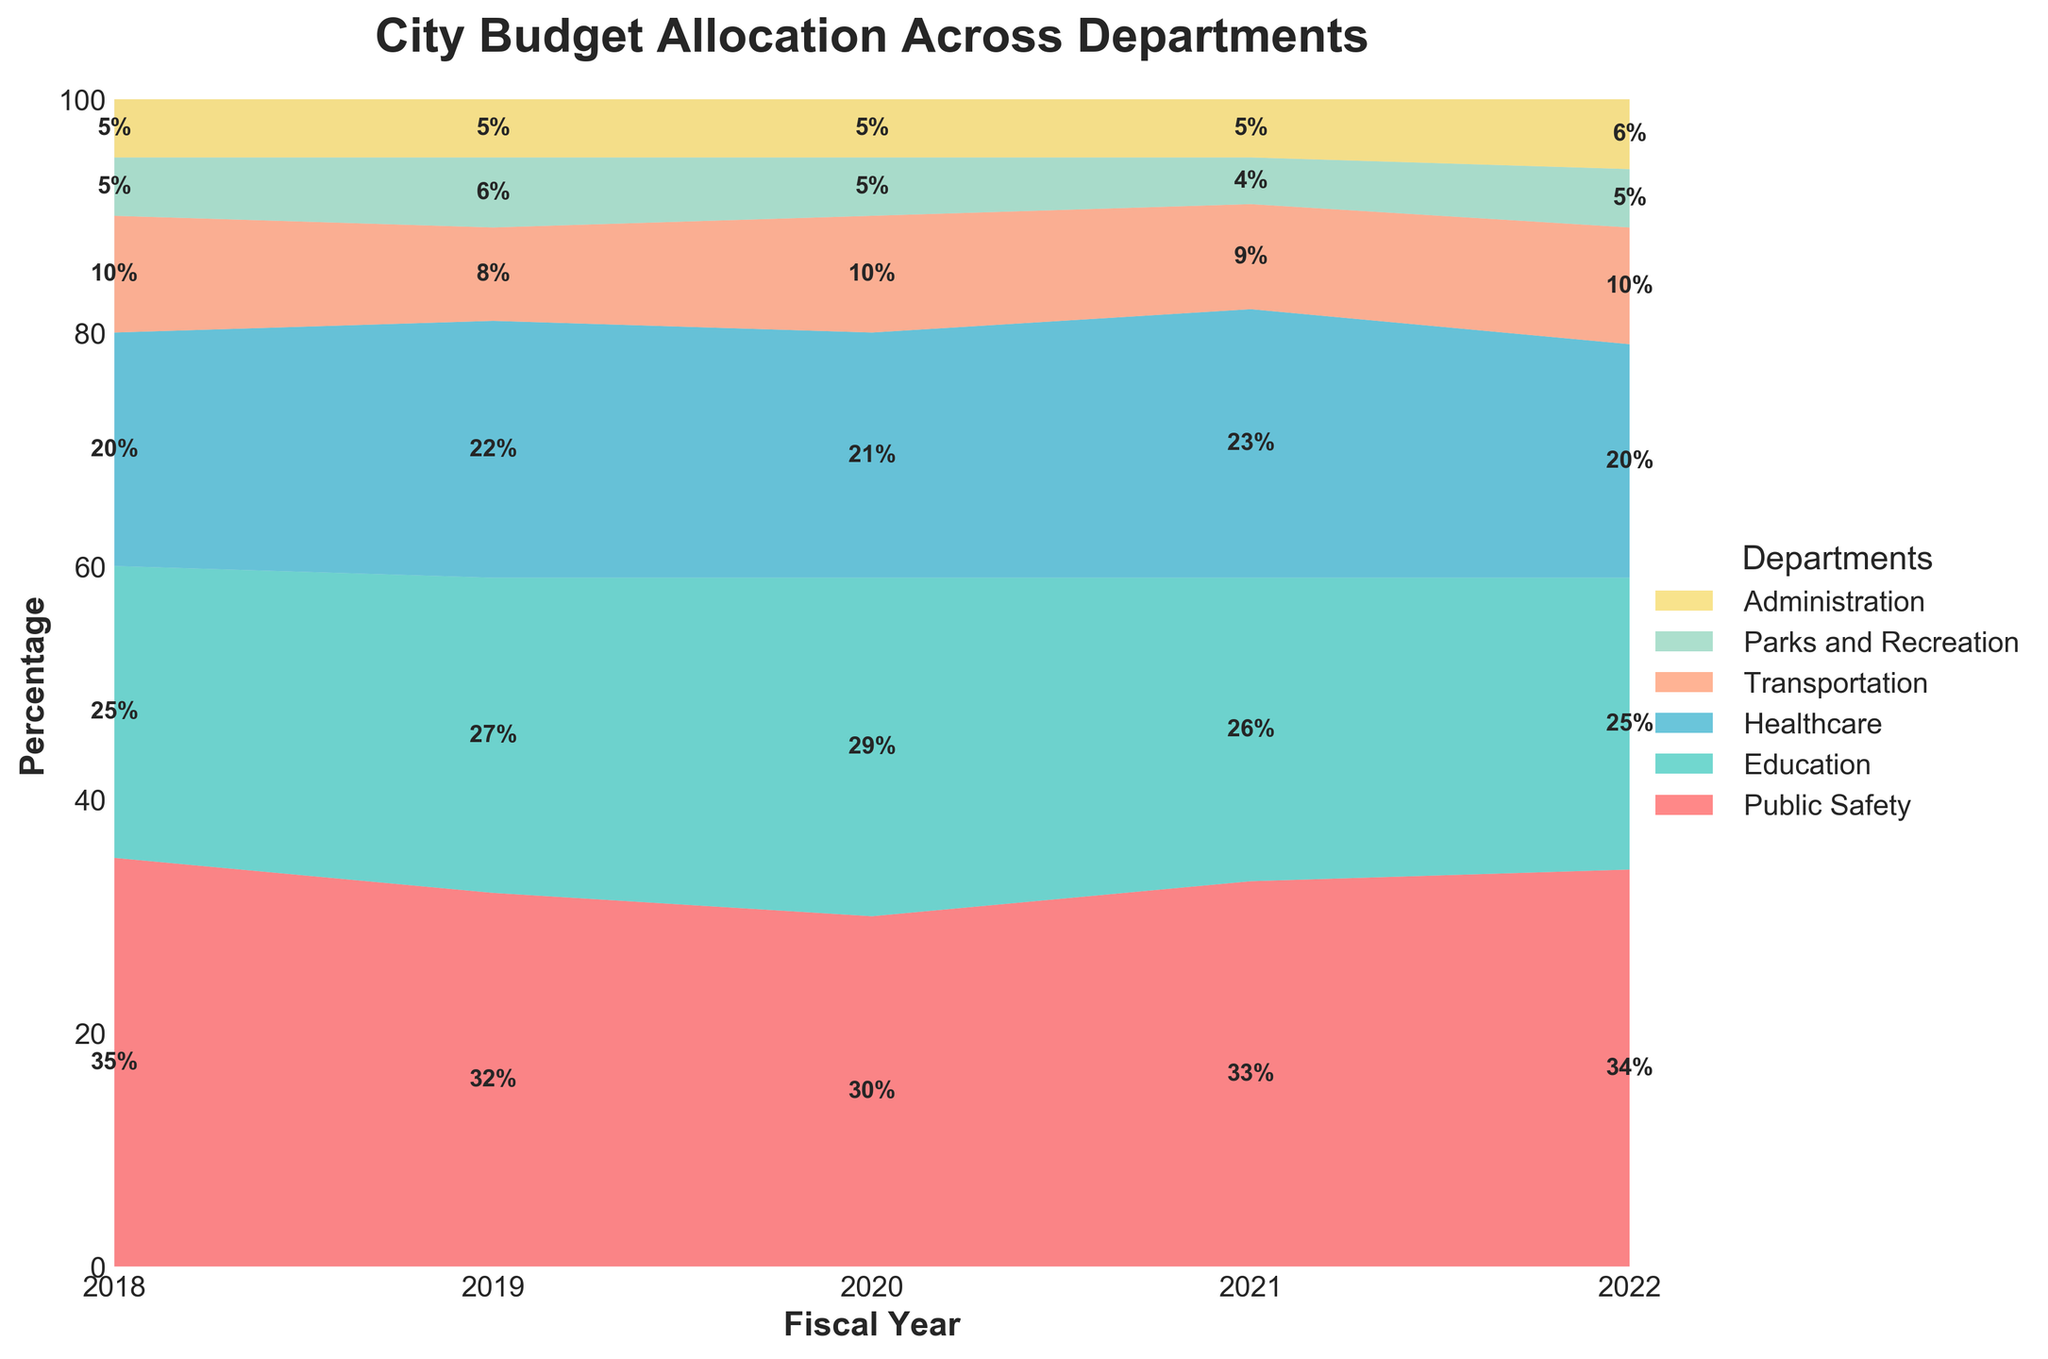What is the title of the chart? The title of the chart is usually positioned at the top and provides an overview of the chart content. In this case, it reads "City Budget Allocation Across Departments".
Answer: City Budget Allocation Across Departments Which department had the highest percentage of the budget in 2018? By looking at the stacked areas for 2018 and the accompanying text annotations, we can see the department with the largest area. Public Safety has the largest area and an annotation of 35%.
Answer: Public Safety How did the budget allocation for Education change from 2018 to 2019? To find the difference, look at the percentages for Education in both years. In 2018, it was 25%, and in 2019, it increased to 27%. The change is 27% - 25%.
Answer: Increased by 2% Which department saw the most significant increase in budget allocation between 2020 and 2021? Compare the percentage values for each department in 2020 and 2021. The most significant increase is from Healthcare, which went from 21% in 2020 to 23% in 2021, a 2% increase.
Answer: Healthcare What is the overall trend for the Parks and Recreation budget allocation from 2018 to 2022? Observe the percentage values year by year. Parks and Recreation went from 5% in 2018, to 6% in 2019, back to 5% in 2020, 4% in 2021, and 5% in 2022. The trend is relatively stable but slightly decreasing overall.
Answer: Slightly decreasing Which year had the highest allocation for Transportation? Look at the area corresponding to Transportation across all years and note the one that reaches the highest point. Both 2018 and 2022 have an allocation of 10%, but the highest singular allocation over the years is in 2020 at 10%.
Answer: 2020 Compare the allocation for Administration in 2020 and 2022. Which is higher? Look at the allocation percentage for Administration in both years. It is 5% in 2020 and 6% in 2022. Therefore, 2022 is higher.
Answer: 2022 What is the sum of the budget allocations for Public Safety and Healthcare in 2021? Add the percentages for Public Safety and Healthcare in 2021. Public Safety is 33% and Healthcare is 23%. 33% + 23% = 56%.
Answer: 56% Which department consistently received 5% of the budget from 2018 to 2021 but saw an increase in 2022? By looking at the consistent percent values across years and identifying a change in 2022, it is the Administration department which consistently received 5% from 2018 to 2021 and increased to 6% in 2022.
Answer: Administration Which fiscal year showed the lowest allocation for Education? Compare all percentages for Education from each year. The lowest allocation for Education is found in 2021 at 26%.
Answer: 2021 